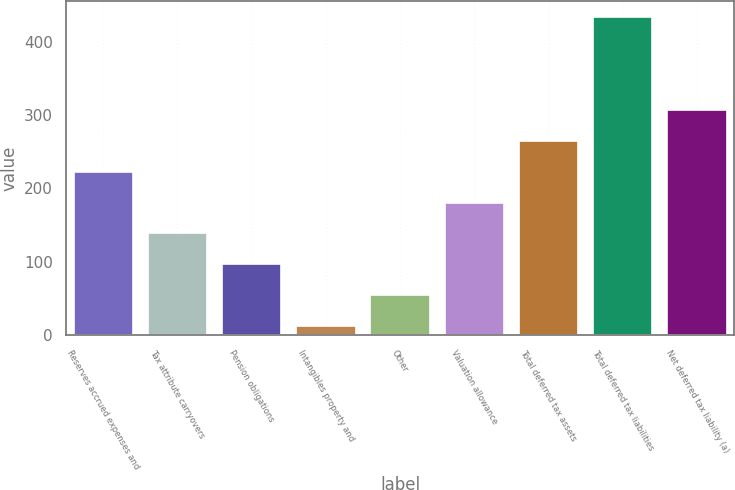Convert chart to OTSL. <chart><loc_0><loc_0><loc_500><loc_500><bar_chart><fcel>Reserves accrued expenses and<fcel>Tax attribute carryovers<fcel>Pension obligations<fcel>Intangibles property and<fcel>Other<fcel>Valuation allowance<fcel>Total deferred tax assets<fcel>Total deferred tax liabilities<fcel>Net deferred tax liability (a)<nl><fcel>222.85<fcel>138.55<fcel>96.4<fcel>12.1<fcel>54.25<fcel>180.7<fcel>265<fcel>433.6<fcel>307.15<nl></chart> 